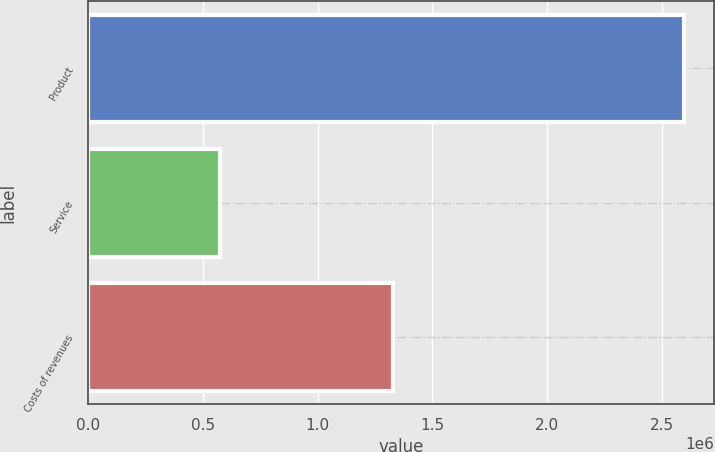Convert chart. <chart><loc_0><loc_0><loc_500><loc_500><bar_chart><fcel>Product<fcel>Service<fcel>Costs of revenues<nl><fcel>2.59776e+06<fcel>574189<fcel>1.33002e+06<nl></chart> 